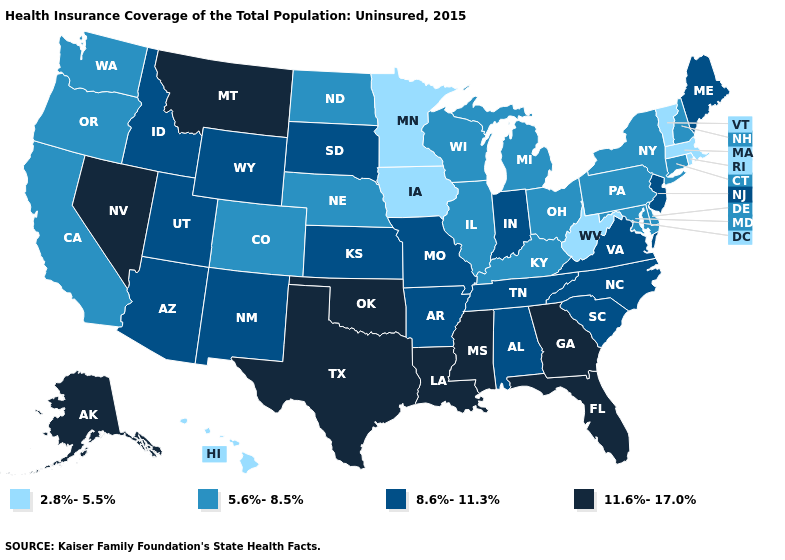Does Hawaii have the same value as Alaska?
Keep it brief. No. What is the value of Louisiana?
Short answer required. 11.6%-17.0%. What is the highest value in states that border Rhode Island?
Answer briefly. 5.6%-8.5%. What is the value of Kentucky?
Quick response, please. 5.6%-8.5%. What is the highest value in the USA?
Quick response, please. 11.6%-17.0%. Name the states that have a value in the range 8.6%-11.3%?
Short answer required. Alabama, Arizona, Arkansas, Idaho, Indiana, Kansas, Maine, Missouri, New Jersey, New Mexico, North Carolina, South Carolina, South Dakota, Tennessee, Utah, Virginia, Wyoming. Does Florida have the highest value in the USA?
Be succinct. Yes. Among the states that border Wisconsin , does Illinois have the lowest value?
Write a very short answer. No. What is the value of North Dakota?
Concise answer only. 5.6%-8.5%. Among the states that border North Carolina , does South Carolina have the lowest value?
Quick response, please. Yes. What is the highest value in states that border California?
Short answer required. 11.6%-17.0%. How many symbols are there in the legend?
Short answer required. 4. Does Arizona have the same value as South Carolina?
Short answer required. Yes. What is the value of Arkansas?
Be succinct. 8.6%-11.3%. Does Minnesota have the lowest value in the USA?
Answer briefly. Yes. 